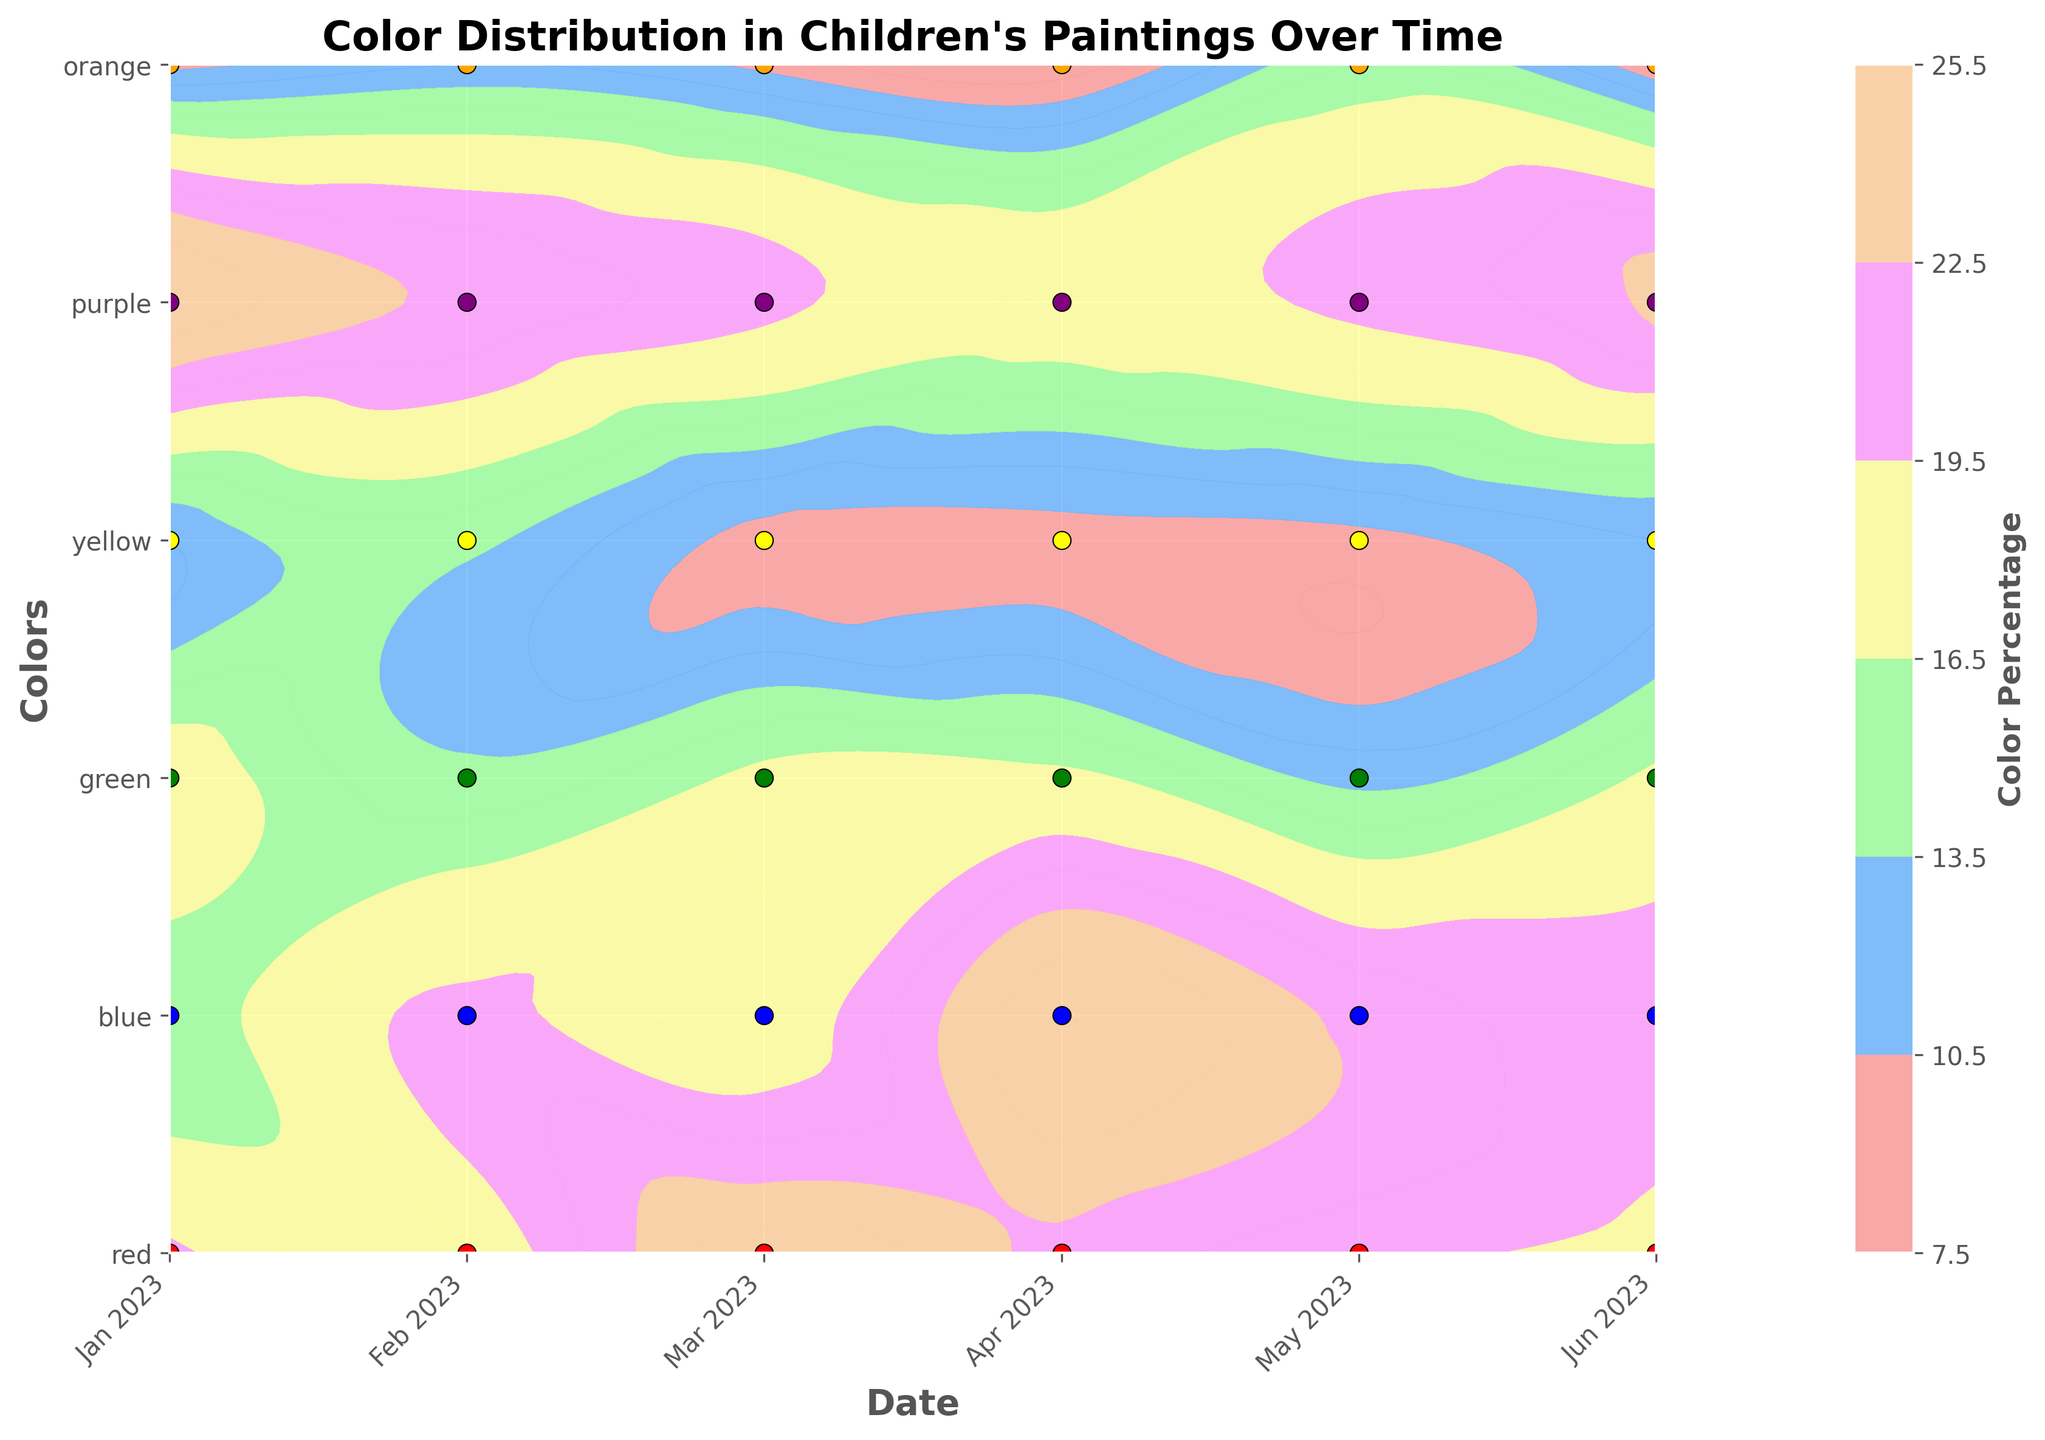What is the title of the figure? The title is prominently displayed at the top of the figure. It reads "Color Distribution in Children's Paintings Over Time."
Answer: Color Distribution in Children's Paintings Over Time What colors are included in the figure? The y-axis lists six different colors that are included in the analysis. These colors are red, blue, green, yellow, purple, and orange.
Answer: red, blue, green, yellow, purple, orange Which month shows the highest percentage for the color green? To find this, locate the color green on the y-axis and then trace horizontally to see the highest contour level. From the plot, it is in April 2023.
Answer: April 2023 How does the percentage of red evolve over time? Trace the green color along the y-axis and observe the variations of contour levels for each month along the x-axis. The percentage of red color generally decreases from January to April but then increases again towards June.
Answer: decreases, then increases What is the overall trend for the color blue from January to June? Observe the contour levels corresponding to the color blue along the timeline. Blue percentages generally increase slightly over time, peaking in March and April and then slightly decreasing in the later months.
Answer: peaks in March and April, then decreases slightly Which two months have nearly equal usage percentages for blue and red? Compare the contour levels representing blue and red colors across all months. In May 2023 and June 2023, the contour levels indicate nearly equal usage percentages for both colors.
Answer: May 2023, June 2023 Are there any months where yellow is least used? By examining the contour plot for the color yellow, we can see the lowest contour levels in April 2023, indicating minimal usage.
Answer: April 2023 What are the ranges of color percentages represented in the figure? The color bar on the side of the plot provides a visual scale indicating color percentage ranges. The range is from the lowest around 8% to the highest close to 25%.
Answer: 8% to 25% How do the color distributions for purple compare from January to June? Observe the contour levels for purple by tracing horizontally across all months. Purple shows a slight increase in usage percentages at the beginning and then stabilizes around the mid to lower percentage range.
Answer: slight increase, then stabilizes Which colors show a consistent percentage of use over the months? By examining the contour plot, orange and yellow have relatively consistent contour levels across the timeline, indicating stable percentage usage.
Answer: orange, yellow 